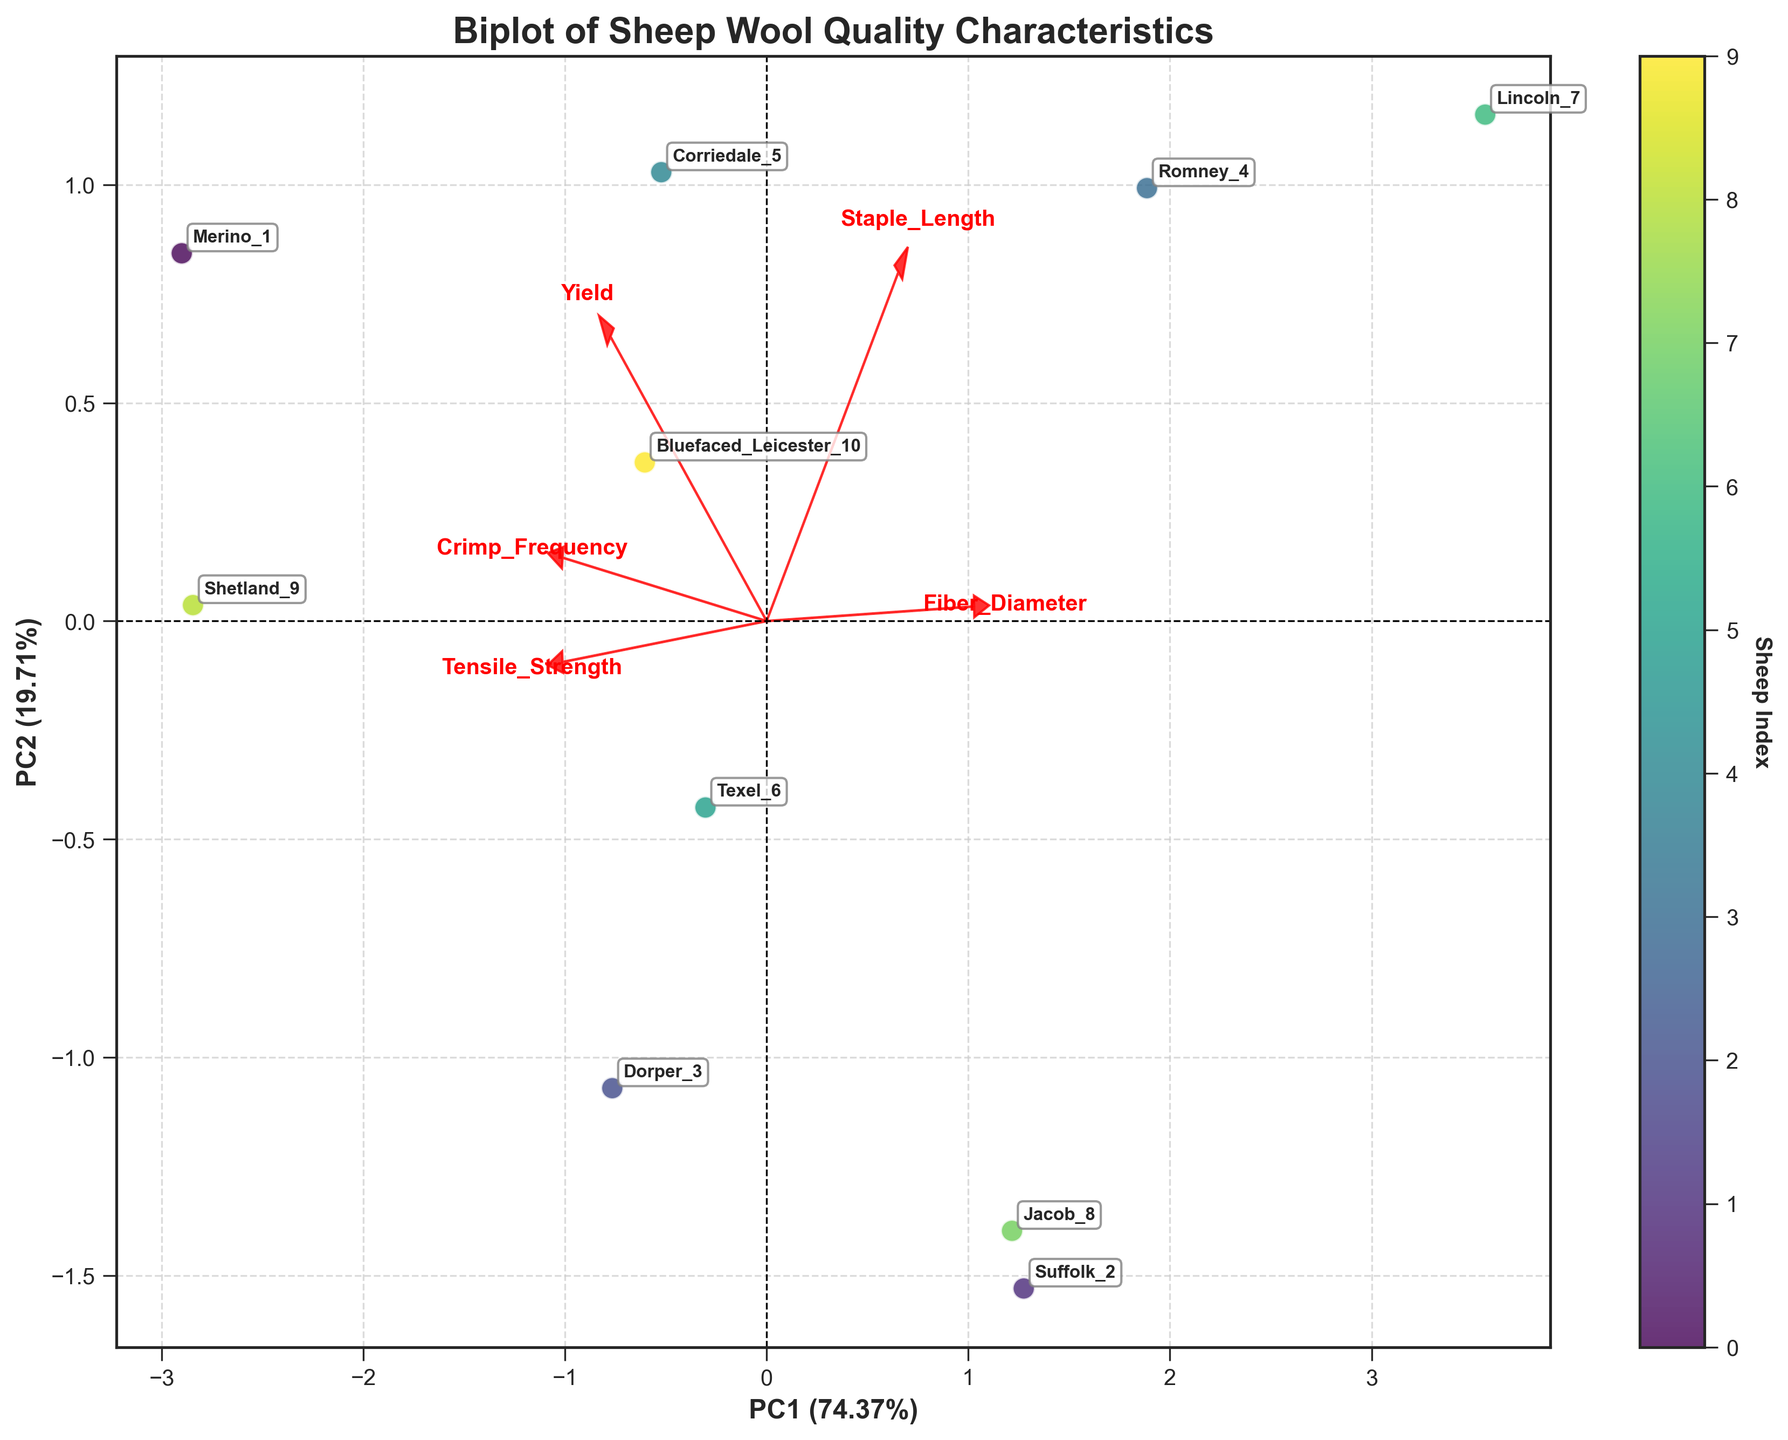What is the title of the plot? The title is displayed at the top of the plot, usually in a larger and bolder font.
Answer: Biplot of Sheep Wool Quality Characteristics How many data points are there in the plot? Each data point represents a sheep, annotated with its ID. Count the number of annotations.
Answer: 10 What percentage of variation is explained by the first principal component (PC1)? Look at the x-axis label which mentions the percentage of variation explained by PC1.
Answer: 58.70% Which sheep has the highest tensile strength and where is it located on the plot? Tensile strength vector points upwards, find the sheep furthest along this direction.
Answer: Shetland_9 Which feature has the largest loading on the second principal component (PC2)? Look at the vectors, and see which feature vector extends furthest along the y-axis (PC2).
Answer: Tensile Strength Which sheep has the shortest staple length and where is it located on the plot? Staple_length vector points towards the negative direction on the PC1 axis, find the sheep closest to the origin in the negative direction along PC1.
Answer: Shetland_9 What is the relationship between fiber diameter and crimp frequency based on the plot? Compare the direction of the vectors for fiber diameter and crimp frequency. If they point in similar directions, they are positively correlated; if opposite, they are negatively correlated.
Answer: Negatively correlated Is there any sheep with a high fiber diameter, long staple length, and low crimp frequency? If so, which one? Look for a sheep that is located in the same general direction as both the fiber diameter and staple length vectors but in the opposite direction of crimp frequency.
Answer: Lincoln_7 Which two features are most positively correlated? Vectors pointing in nearly the same direction indicate positive correlation. Compare all vectors to determine the closest.
Answer: Fiber Diameter and Staple Length Which sheep has a yield closest to the axis origin? Look for the data point nearest to the center of the plot where the axes meet.
Answer: Suffolk_2 